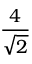Convert formula to latex. <formula><loc_0><loc_0><loc_500><loc_500>\frac { 4 } { \sqrt { 2 } }</formula> 